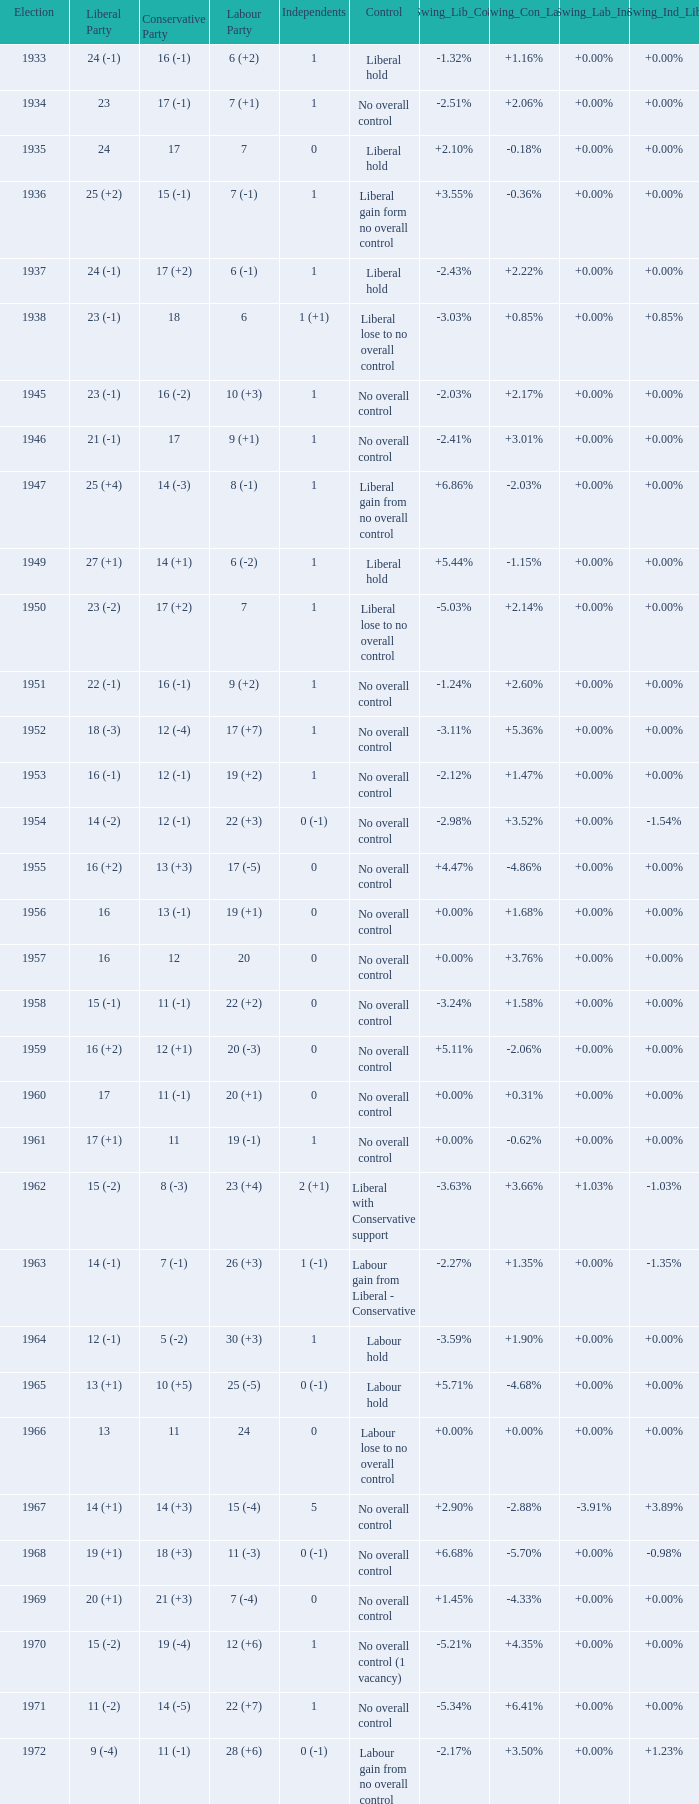What is the number of Independents elected in the year Labour won 26 (+3) seats? 1 (-1). 